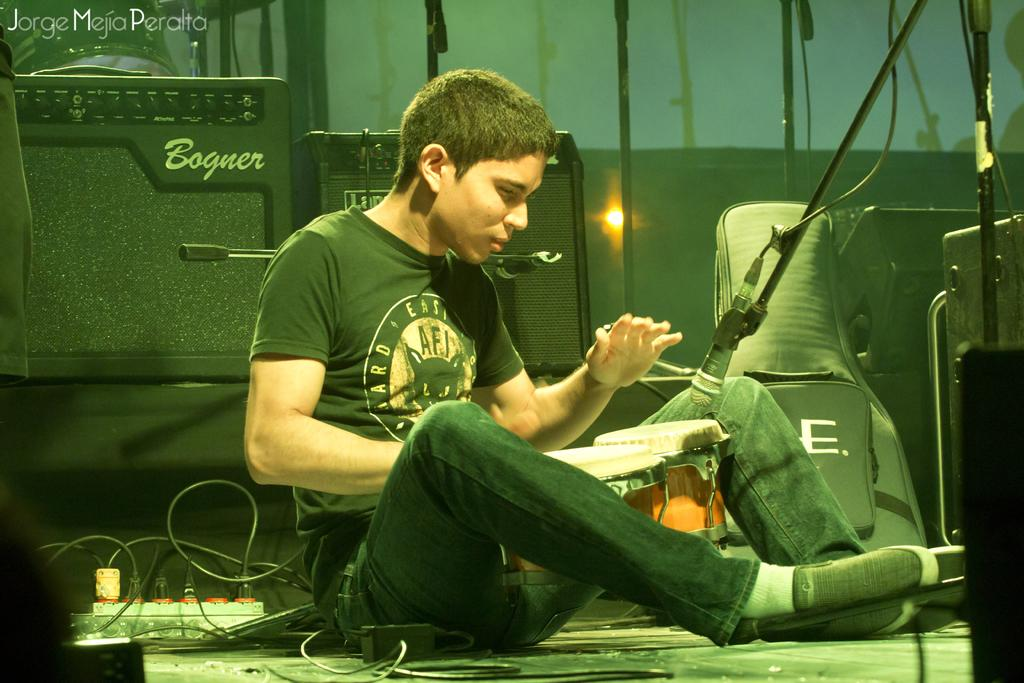What is the man in the image doing? The man is sitting in the image. What object is visible near the man? There is a bag in the image. What musical instruments are present in the image? There are drums in the image. What can be seen on the floor in the image? There are cables on the floor in the image. What device is in front of the man? There is a microphone in front of the man. What equipment is visible in the background of the image? There are speakers in the background of the image. Can you describe any other objects visible in the background of the image? There are other objects visible in the background of the image, but their specific details are not mentioned in the provided facts. What type of iron can be seen in the image? There is no iron present in the image. Can you tell me how many vans are visible in the image? There is no van present in the image. What animals can be seen at the zoo in the image? There is no zoo or animals present in the image. 